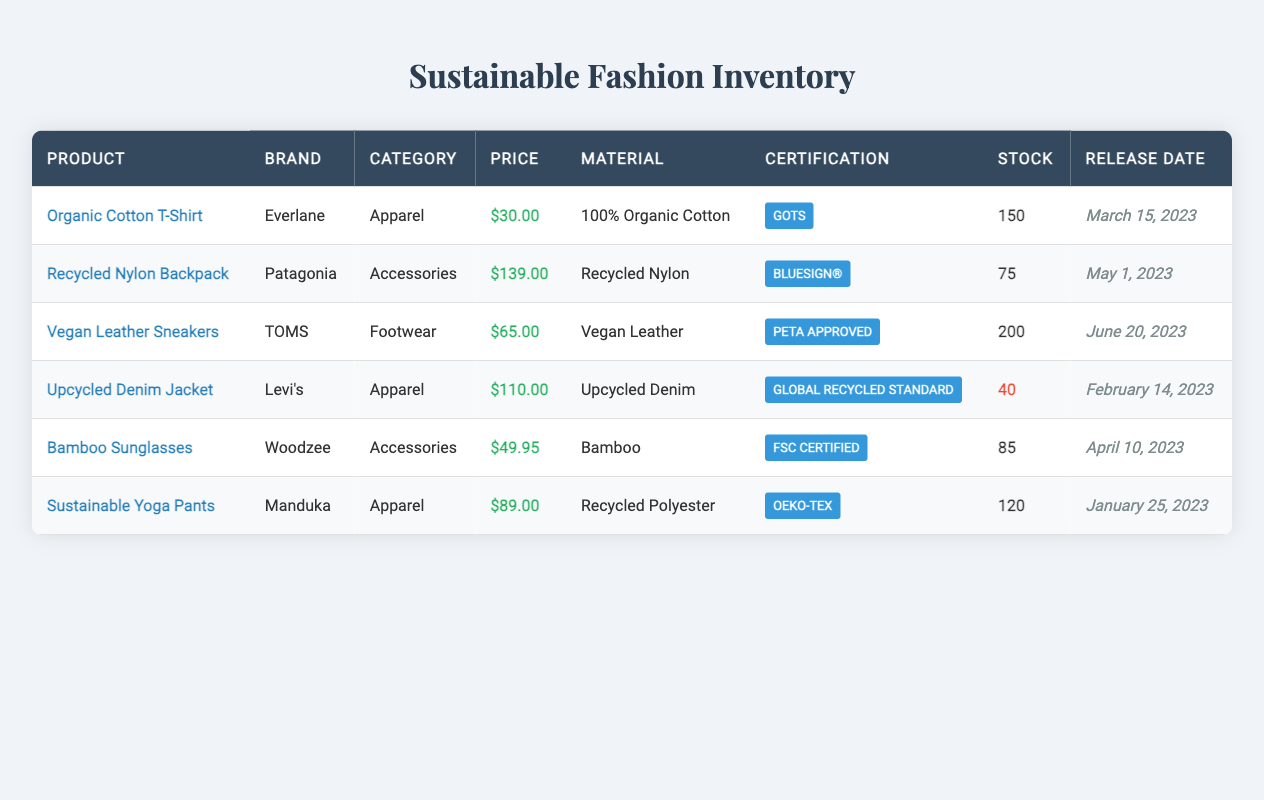What is the price of the Organic Cotton T-Shirt? The price is listed directly in the table under the price column for the Organic Cotton T-Shirt.
Answer: 30.00 How many units of the Recycled Nylon Backpack are in stock? The quantity in stock is provided in the stock column for the Recycled Nylon Backpack, which lists 75 units available.
Answer: 75 Which product has the highest price? By comparing the prices listed for each product, the Recycled Nylon Backpack at 139.00 is the highest price among all listed products.
Answer: 139.00 What material is used to make the Vegan Leather Sneakers? The material is indicated in the material column for the Vegan Leather Sneakers, which shows it is made of Vegan Leather.
Answer: Vegan Leather What is the total stock of all apparel items? The stock for apparel items includes the Organic Cotton T-Shirt (150), Upcycled Denim Jacket (40), and Sustainable Yoga Pants (120). Summing these gives 150 + 40 + 120 = 310.
Answer: 310 Is the Upcycled Denim Jacket in low stock? The stock status is listed for the Upcycled Denim Jacket, where it shows 40 units. Generally, this would be considered a low stock based on typical expectations.
Answer: Yes Which brand has products made from sustainable materials certified by GOTS? The Organic Cotton T-Shirt by Everlane is the only item that has a sustainability certification from GOTS. Checking the brand list confirms this.
Answer: Everlane What percentage of the stock is made up of Vegan Leather Sneakers? There are 200 Vegan Leather Sneakers and the total stock across all items is 150 + 75 + 200 + 40 + 85 + 120 = 670. To find the percentage: (200 / 670) * 100 = 29.85%.
Answer: 29.85% Which product was released most recently? The release dates are listed for each product. The most recent date is June 20, 2023, for the Vegan Leather Sneakers, making it the latest release.
Answer: Vegan Leather Sneakers How many products have a sustainability certification from FSC? In the table, only the Bamboo Sunglasses by Woodzee is listed with the FSC certification. Therefore, there is only one product with this certification.
Answer: 1 